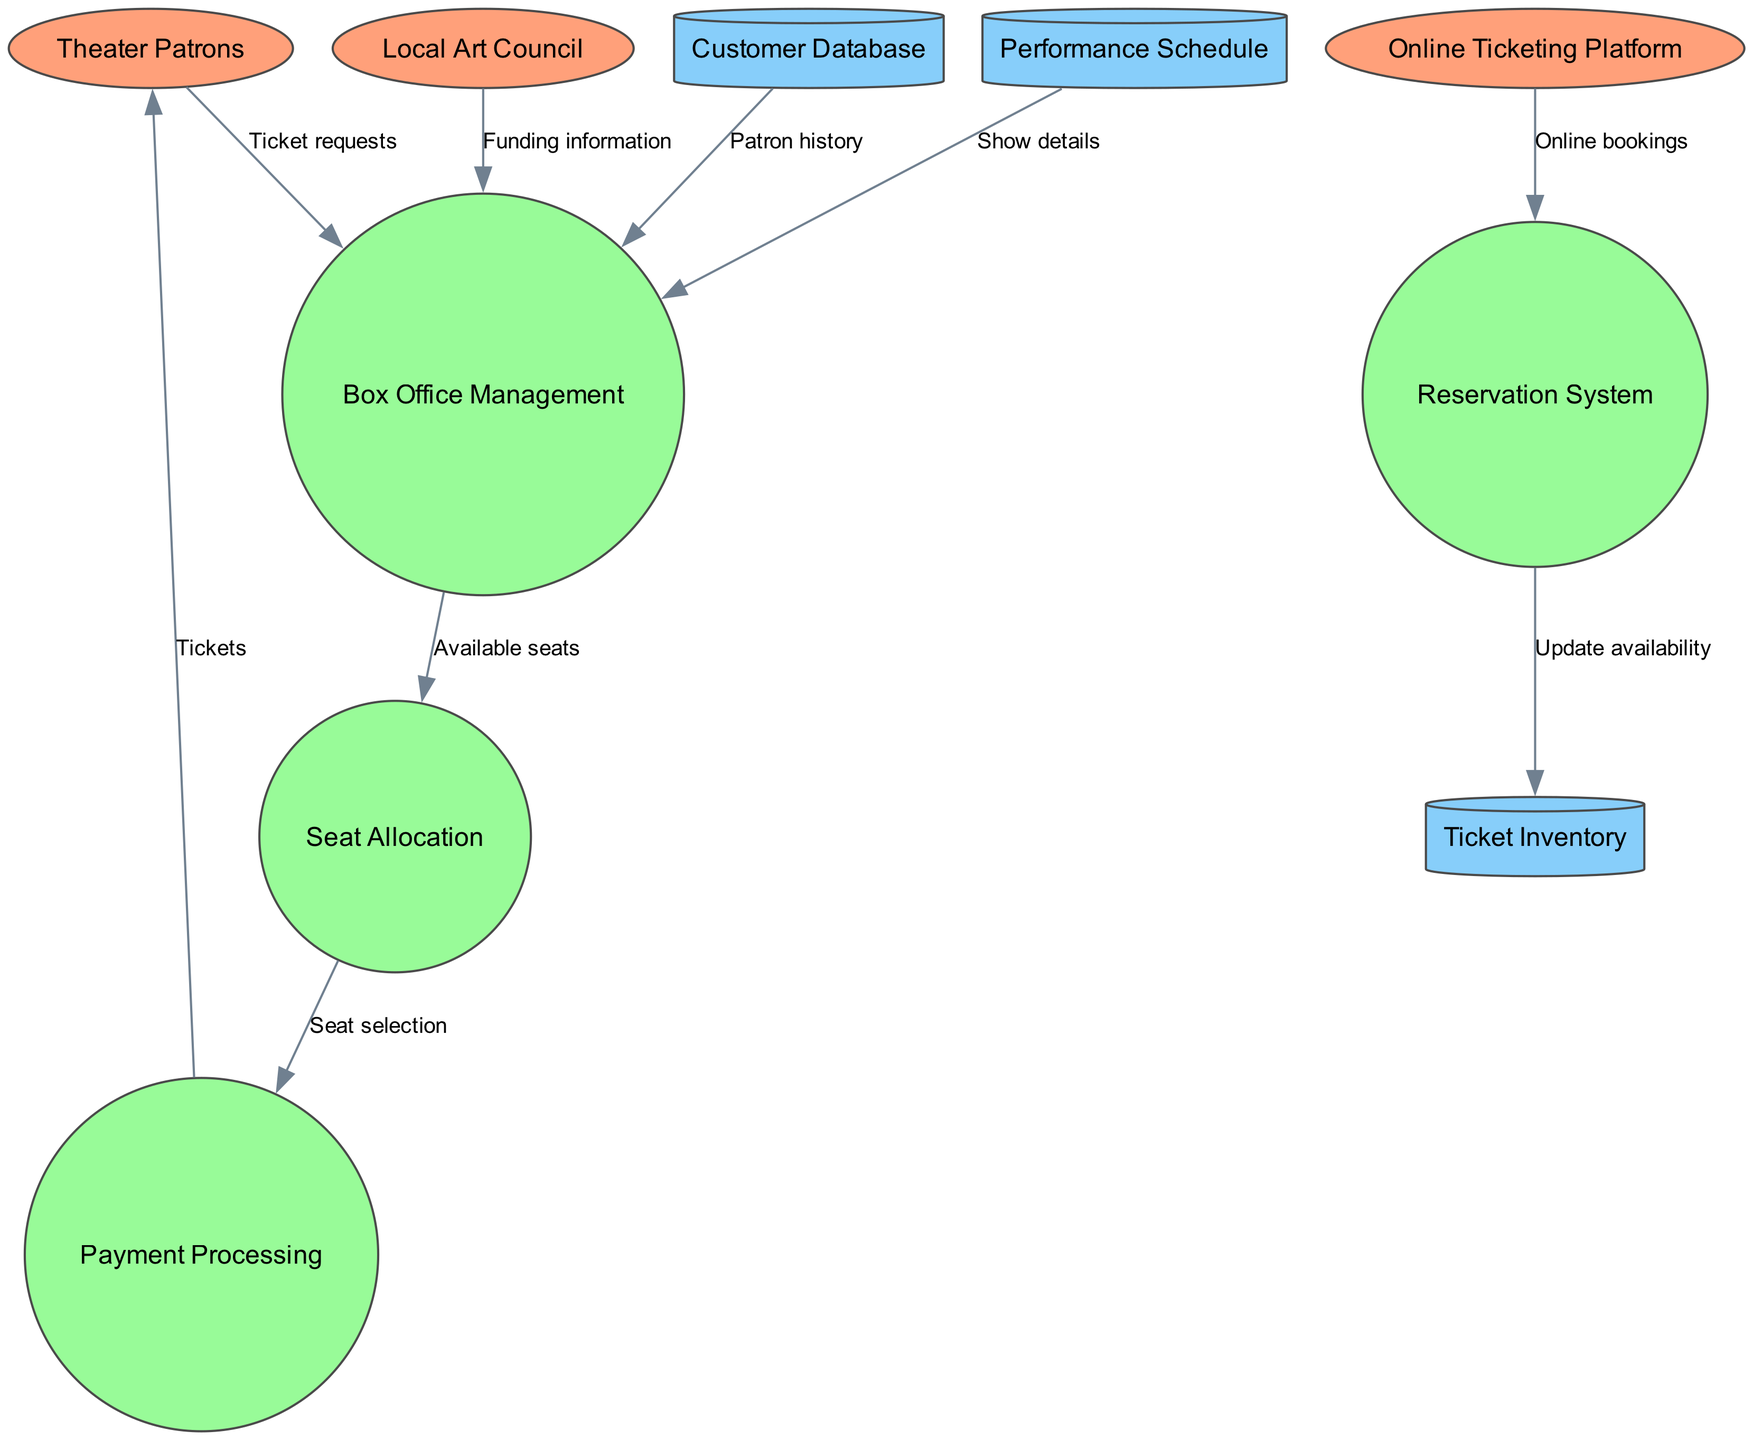What are the external entities involved in the system? The external entities listed in the diagram are the primary interacting components that send or receive data. By identifying the labeled ellipses, we see that "Theater Patrons," "Local Art Council," and "Online Ticketing Platform" are the external entities.
Answer: Theater Patrons, Local Art Council, Online Ticketing Platform Which process receives ticket requests from patrons? In the diagram, there is a directed flow from "Theater Patrons" to "Box Office Management" labeled "Ticket requests." This indicates that the "Box Office Management" process is responsible for receiving ticket requests.
Answer: Box Office Management How many data stores are present in the diagram? The diagram outlines specific components classified as data stores. Counting the cylindrical shapes, we find there are three data stores: "Customer Database," "Performance Schedule," and "Ticket Inventory."
Answer: 3 What type of information is sent from the "Local Art Council" to "Box Office Management"? The labeled flow from "Local Art Council" to "Box Office Management" indicates that the information sent is referred to as "Funding information." Thus, the type of information corresponds to funding details provided to the theater.
Answer: Funding information Which process directly updates the ticket availability in inventory? The flow between "Reservation System" and "Ticket Inventory" is labeled "Update availability," indicating that the "Reservation System" process is responsible for updating the ticket availability based on reservations made.
Answer: Reservation System Which two processes interact directly through data flow after seat selection? The diagram shows a flow from the "Seat Allocation" process to the "Payment Processing" process using the label "Seat selection." Thus, these two processes interact directly through the ticket allocation information.
Answer: Seat Allocation, Payment Processing What information does "Payment Processing" send back to "Theater Patrons"? Looking at the flow from "Payment Processing" to "Theater Patrons," it is clear that the information communicated is "Tickets," which refers to the completed transaction of tickets purchased.
Answer: Tickets Which process retrieves information from the "Customer Database"? Analyzing the flows, "Box Office Management" receives data from "Customer Database" identified as "Patron history." Therefore, "Box Office Management" is the process that retrieves this information.
Answer: Box Office Management 